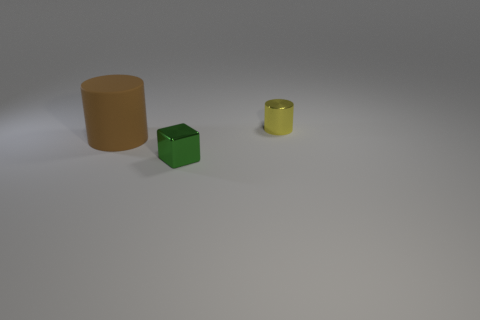How many objects are either red rubber things or small objects behind the big cylinder?
Keep it short and to the point. 1. There is a yellow object that is the same material as the green object; what is its size?
Make the answer very short. Small. There is a object that is to the right of the metal object in front of the brown object; what shape is it?
Make the answer very short. Cylinder. How many yellow things are metal blocks or metallic objects?
Your answer should be very brief. 1. There is a tiny cylinder behind the small metal thing in front of the big brown rubber cylinder; are there any cylinders in front of it?
Give a very brief answer. Yes. Is there anything else that has the same material as the yellow cylinder?
Your response must be concise. Yes. How many large things are either cubes or green rubber things?
Offer a very short reply. 0. There is a small shiny thing in front of the brown rubber thing; is it the same shape as the brown matte object?
Your answer should be compact. No. Are there fewer green metal things than tiny objects?
Keep it short and to the point. Yes. Is there any other thing of the same color as the tiny block?
Provide a succinct answer. No. 